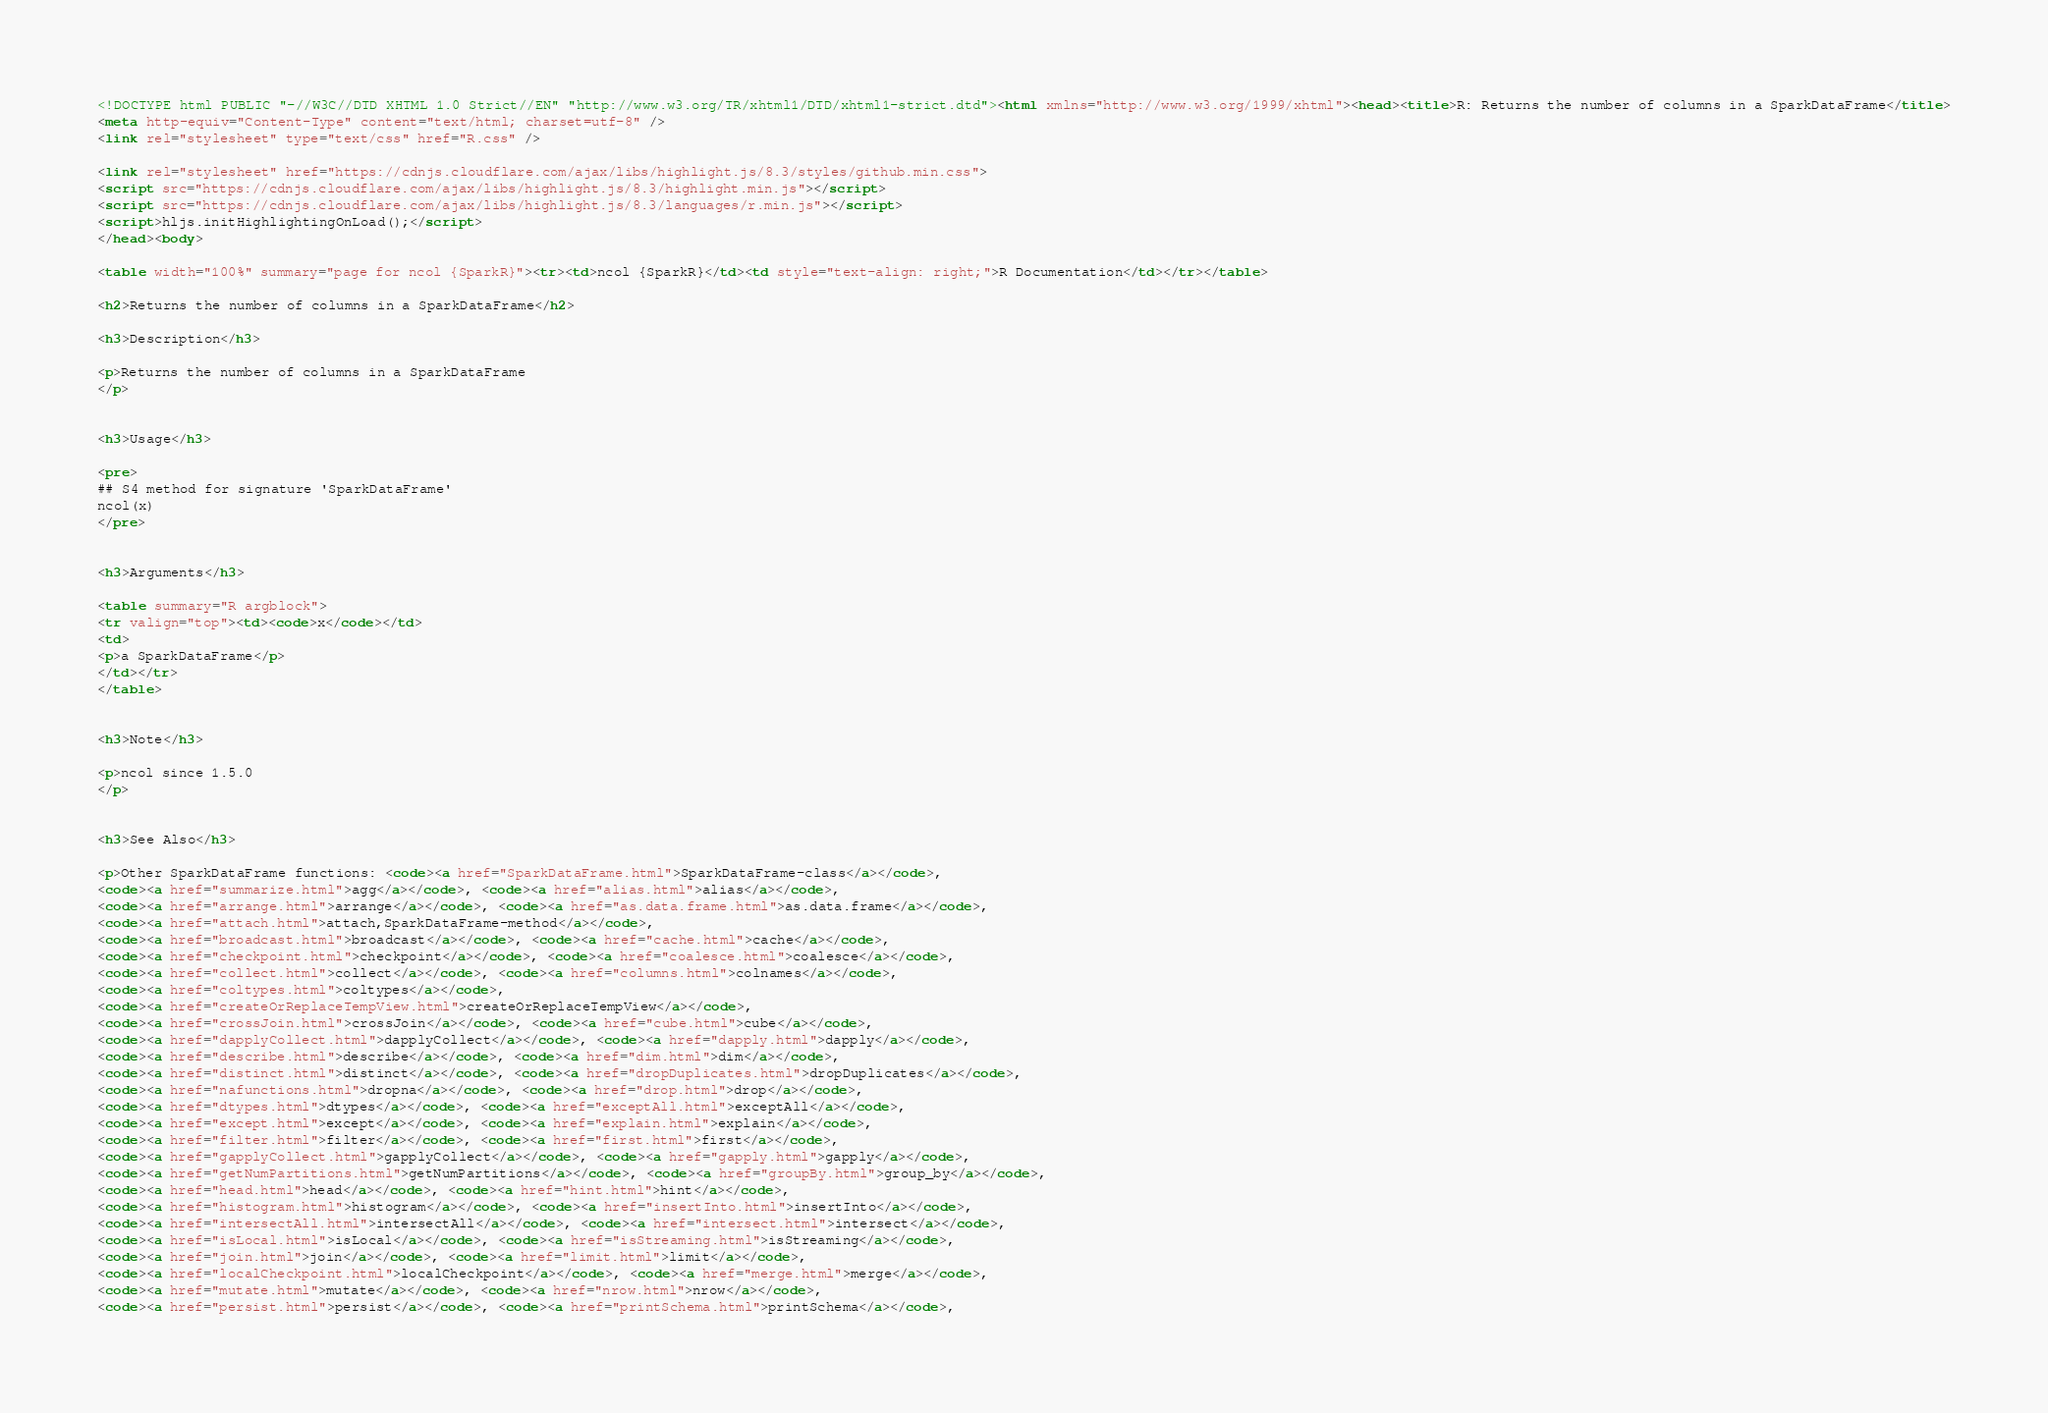Convert code to text. <code><loc_0><loc_0><loc_500><loc_500><_HTML_><!DOCTYPE html PUBLIC "-//W3C//DTD XHTML 1.0 Strict//EN" "http://www.w3.org/TR/xhtml1/DTD/xhtml1-strict.dtd"><html xmlns="http://www.w3.org/1999/xhtml"><head><title>R: Returns the number of columns in a SparkDataFrame</title>
<meta http-equiv="Content-Type" content="text/html; charset=utf-8" />
<link rel="stylesheet" type="text/css" href="R.css" />

<link rel="stylesheet" href="https://cdnjs.cloudflare.com/ajax/libs/highlight.js/8.3/styles/github.min.css">
<script src="https://cdnjs.cloudflare.com/ajax/libs/highlight.js/8.3/highlight.min.js"></script>
<script src="https://cdnjs.cloudflare.com/ajax/libs/highlight.js/8.3/languages/r.min.js"></script>
<script>hljs.initHighlightingOnLoad();</script>
</head><body>

<table width="100%" summary="page for ncol {SparkR}"><tr><td>ncol {SparkR}</td><td style="text-align: right;">R Documentation</td></tr></table>

<h2>Returns the number of columns in a SparkDataFrame</h2>

<h3>Description</h3>

<p>Returns the number of columns in a SparkDataFrame
</p>


<h3>Usage</h3>

<pre>
## S4 method for signature 'SparkDataFrame'
ncol(x)
</pre>


<h3>Arguments</h3>

<table summary="R argblock">
<tr valign="top"><td><code>x</code></td>
<td>
<p>a SparkDataFrame</p>
</td></tr>
</table>


<h3>Note</h3>

<p>ncol since 1.5.0
</p>


<h3>See Also</h3>

<p>Other SparkDataFrame functions: <code><a href="SparkDataFrame.html">SparkDataFrame-class</a></code>,
<code><a href="summarize.html">agg</a></code>, <code><a href="alias.html">alias</a></code>,
<code><a href="arrange.html">arrange</a></code>, <code><a href="as.data.frame.html">as.data.frame</a></code>,
<code><a href="attach.html">attach,SparkDataFrame-method</a></code>,
<code><a href="broadcast.html">broadcast</a></code>, <code><a href="cache.html">cache</a></code>,
<code><a href="checkpoint.html">checkpoint</a></code>, <code><a href="coalesce.html">coalesce</a></code>,
<code><a href="collect.html">collect</a></code>, <code><a href="columns.html">colnames</a></code>,
<code><a href="coltypes.html">coltypes</a></code>,
<code><a href="createOrReplaceTempView.html">createOrReplaceTempView</a></code>,
<code><a href="crossJoin.html">crossJoin</a></code>, <code><a href="cube.html">cube</a></code>,
<code><a href="dapplyCollect.html">dapplyCollect</a></code>, <code><a href="dapply.html">dapply</a></code>,
<code><a href="describe.html">describe</a></code>, <code><a href="dim.html">dim</a></code>,
<code><a href="distinct.html">distinct</a></code>, <code><a href="dropDuplicates.html">dropDuplicates</a></code>,
<code><a href="nafunctions.html">dropna</a></code>, <code><a href="drop.html">drop</a></code>,
<code><a href="dtypes.html">dtypes</a></code>, <code><a href="exceptAll.html">exceptAll</a></code>,
<code><a href="except.html">except</a></code>, <code><a href="explain.html">explain</a></code>,
<code><a href="filter.html">filter</a></code>, <code><a href="first.html">first</a></code>,
<code><a href="gapplyCollect.html">gapplyCollect</a></code>, <code><a href="gapply.html">gapply</a></code>,
<code><a href="getNumPartitions.html">getNumPartitions</a></code>, <code><a href="groupBy.html">group_by</a></code>,
<code><a href="head.html">head</a></code>, <code><a href="hint.html">hint</a></code>,
<code><a href="histogram.html">histogram</a></code>, <code><a href="insertInto.html">insertInto</a></code>,
<code><a href="intersectAll.html">intersectAll</a></code>, <code><a href="intersect.html">intersect</a></code>,
<code><a href="isLocal.html">isLocal</a></code>, <code><a href="isStreaming.html">isStreaming</a></code>,
<code><a href="join.html">join</a></code>, <code><a href="limit.html">limit</a></code>,
<code><a href="localCheckpoint.html">localCheckpoint</a></code>, <code><a href="merge.html">merge</a></code>,
<code><a href="mutate.html">mutate</a></code>, <code><a href="nrow.html">nrow</a></code>,
<code><a href="persist.html">persist</a></code>, <code><a href="printSchema.html">printSchema</a></code>,</code> 